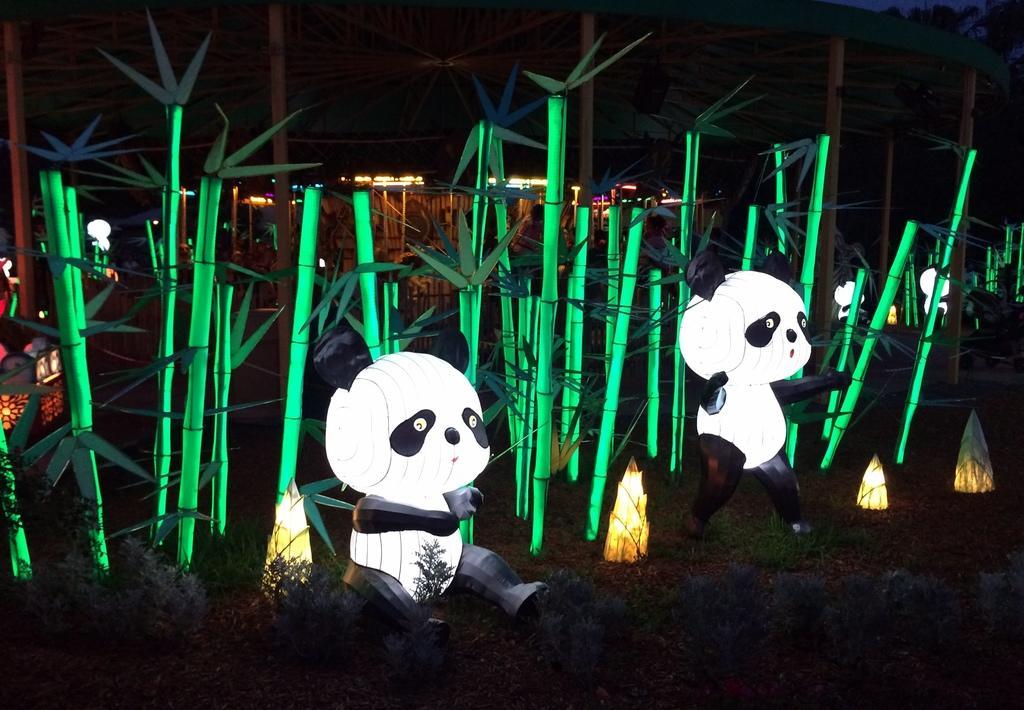Please provide a concise description of this image. Here we can see green sticks, depictions of pandas, plants and lights. Far there are lights.  